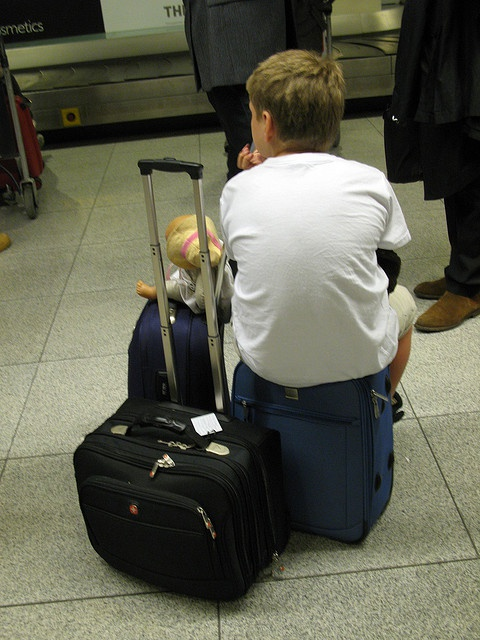Describe the objects in this image and their specific colors. I can see people in black, lightgray, darkgray, and gray tones, suitcase in black, gray, and white tones, people in black, gray, maroon, and olive tones, suitcase in black, navy, gray, and darkgreen tones, and train in black, olive, gray, and darkgreen tones in this image. 